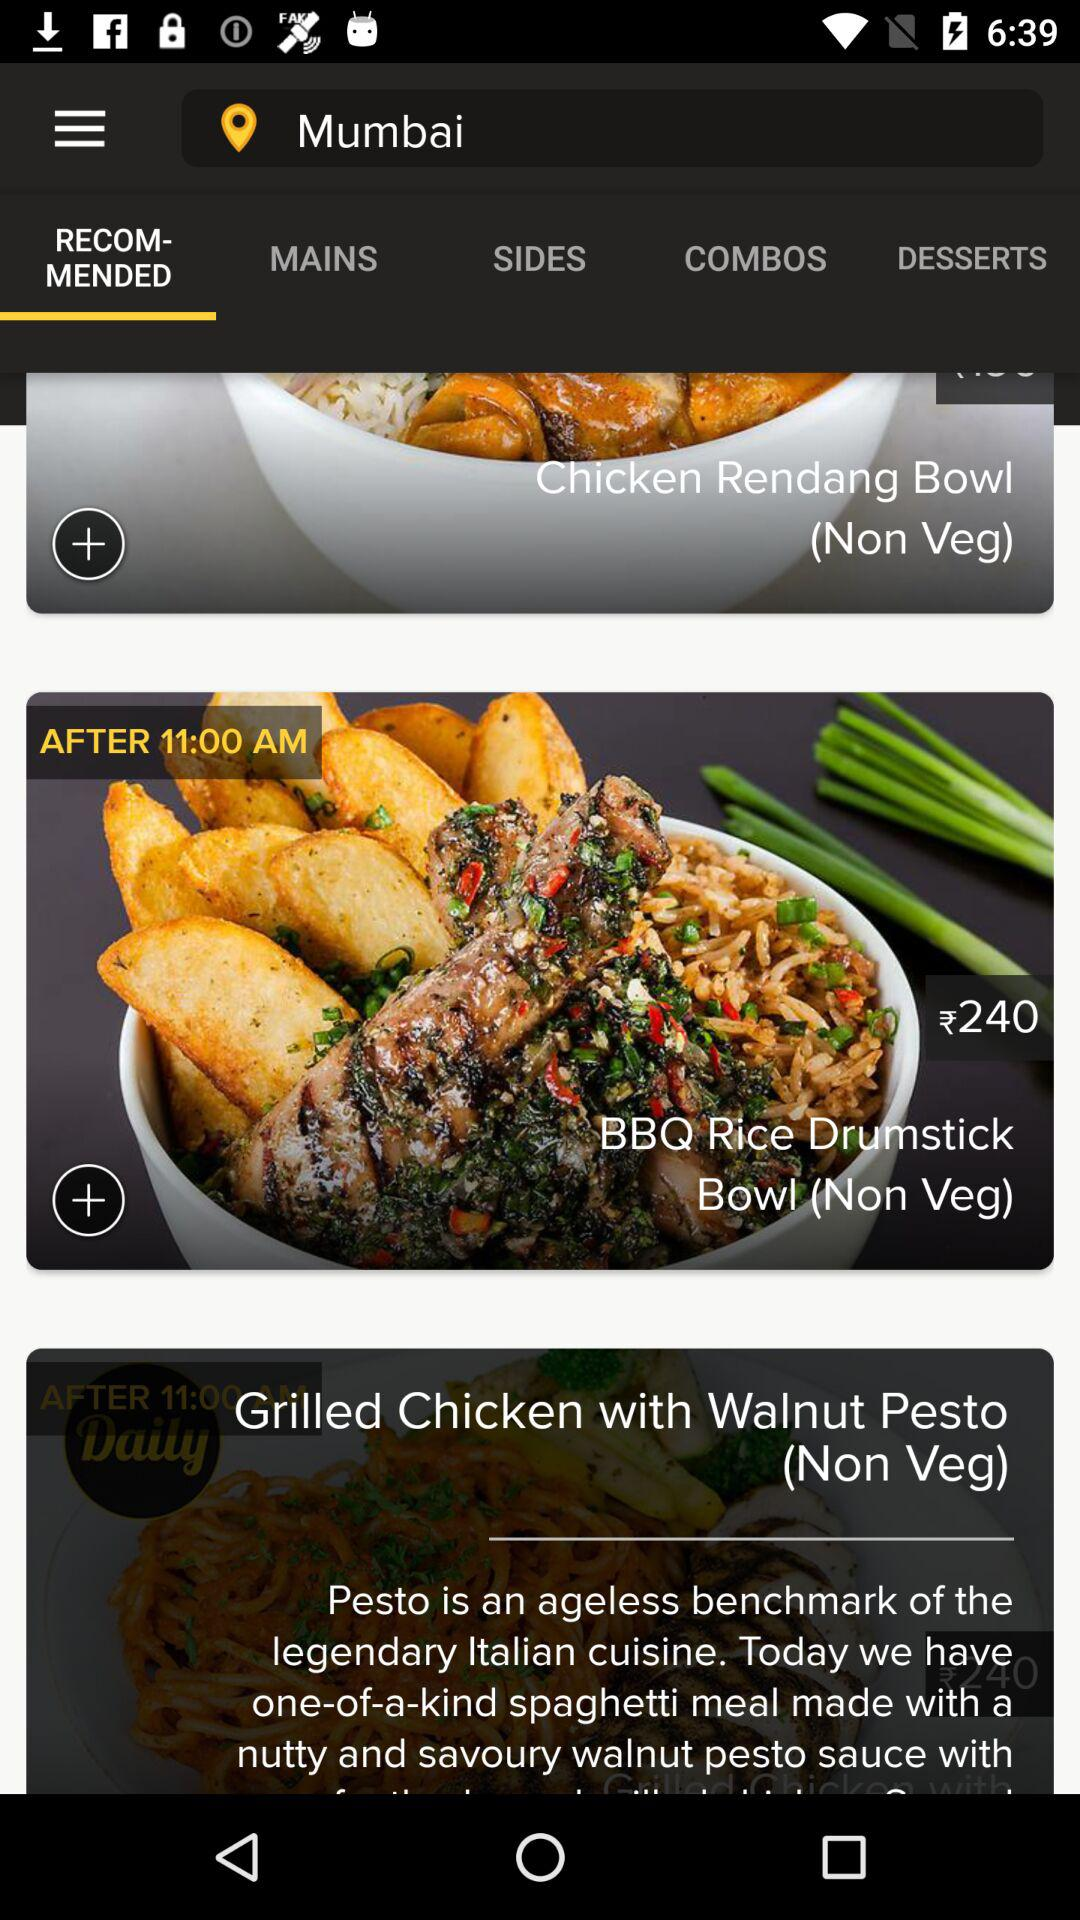Which tab am I on? You are on "RECOMMENDED" tab. 